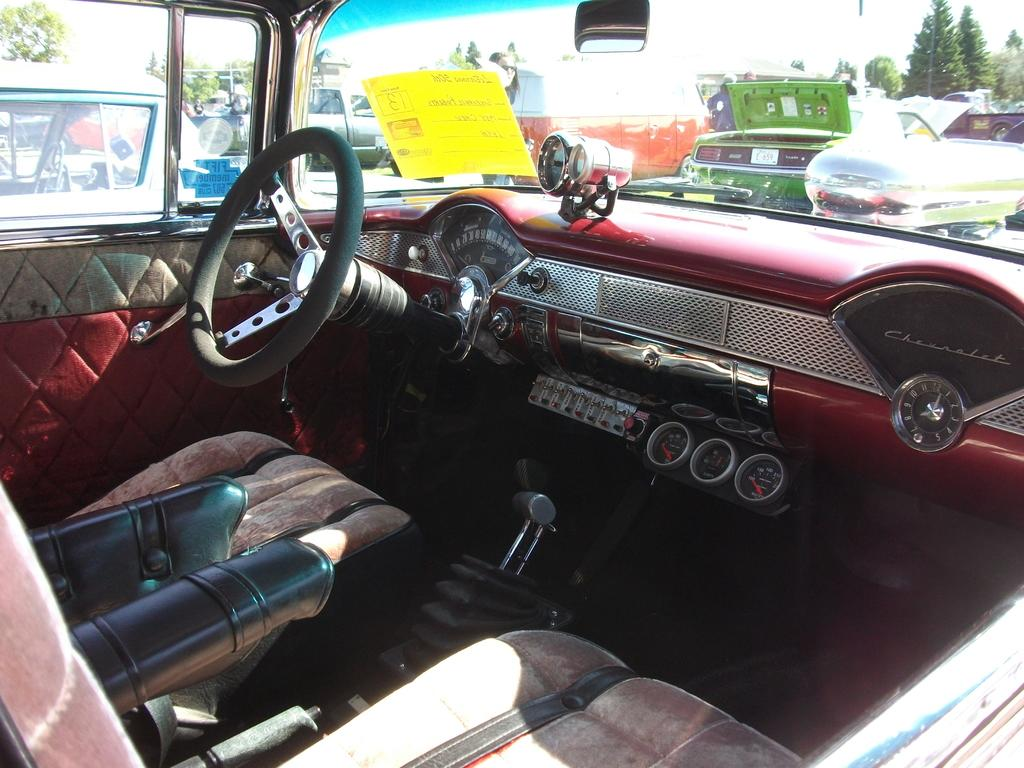What type of vehicles can be seen in the image? There are cars in the image. What is located in the middle of the image? There is a cockpit in the middle of the image. What can be found at the bottom of the image? There are seats at the bottom of the image. What type of vegetation is visible in the top right of the image? There are trees in the top right of the image. Can you find the receipt for the fruit purchase in the image? There is no receipt or fruit purchase present in the image. What type of fruit is shown growing on the trees in the top right of the image? There are no fruit trees visible in the image; only regular trees are present. 